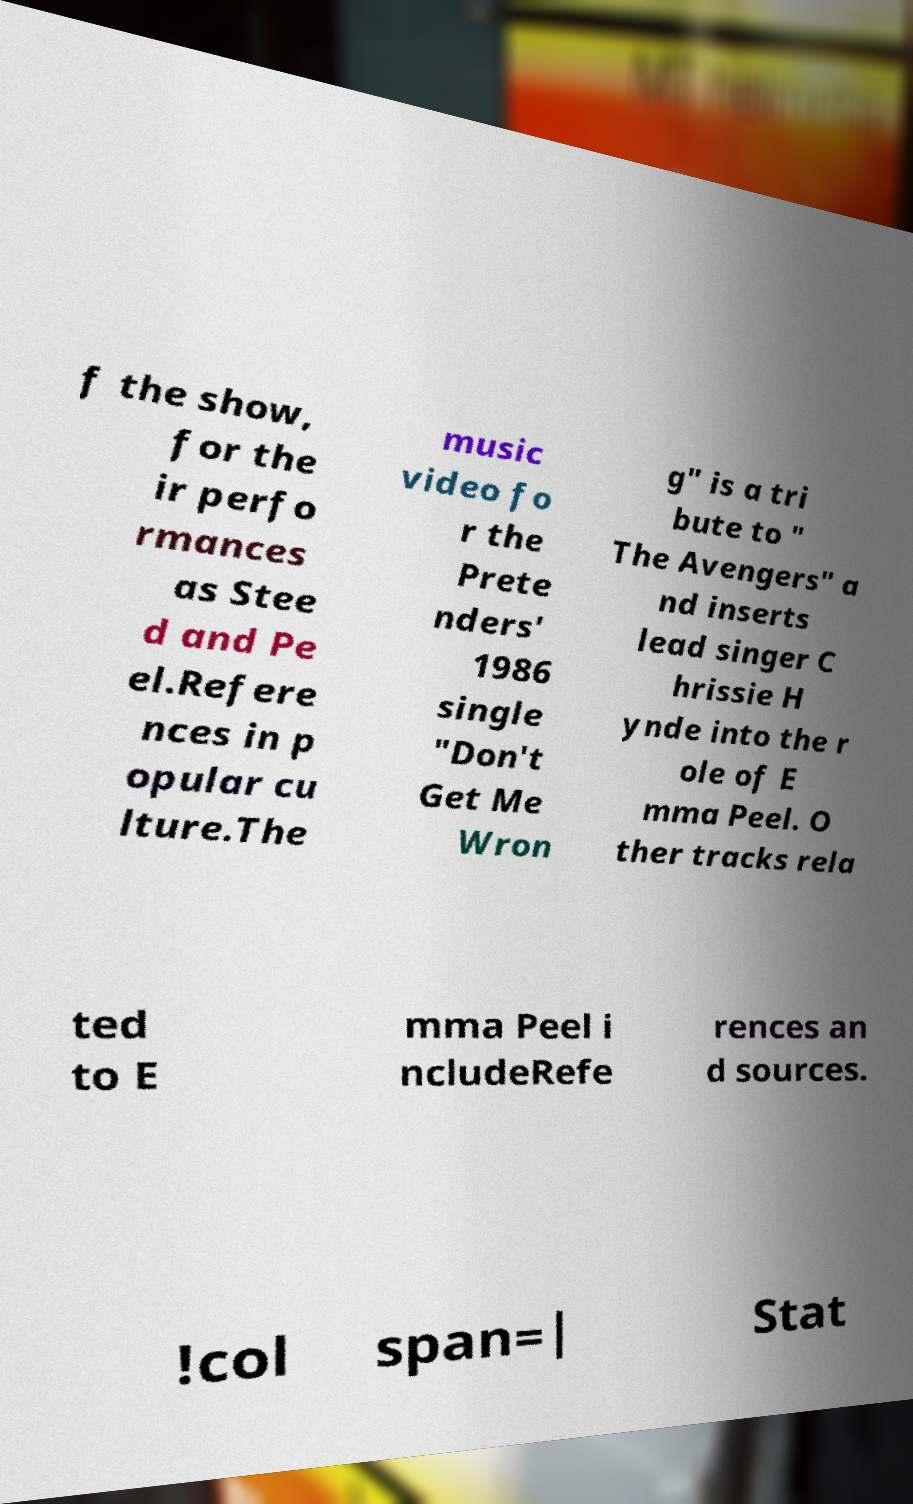Can you accurately transcribe the text from the provided image for me? f the show, for the ir perfo rmances as Stee d and Pe el.Refere nces in p opular cu lture.The music video fo r the Prete nders' 1986 single "Don't Get Me Wron g" is a tri bute to " The Avengers" a nd inserts lead singer C hrissie H ynde into the r ole of E mma Peel. O ther tracks rela ted to E mma Peel i ncludeRefe rences an d sources. !col span=| Stat 